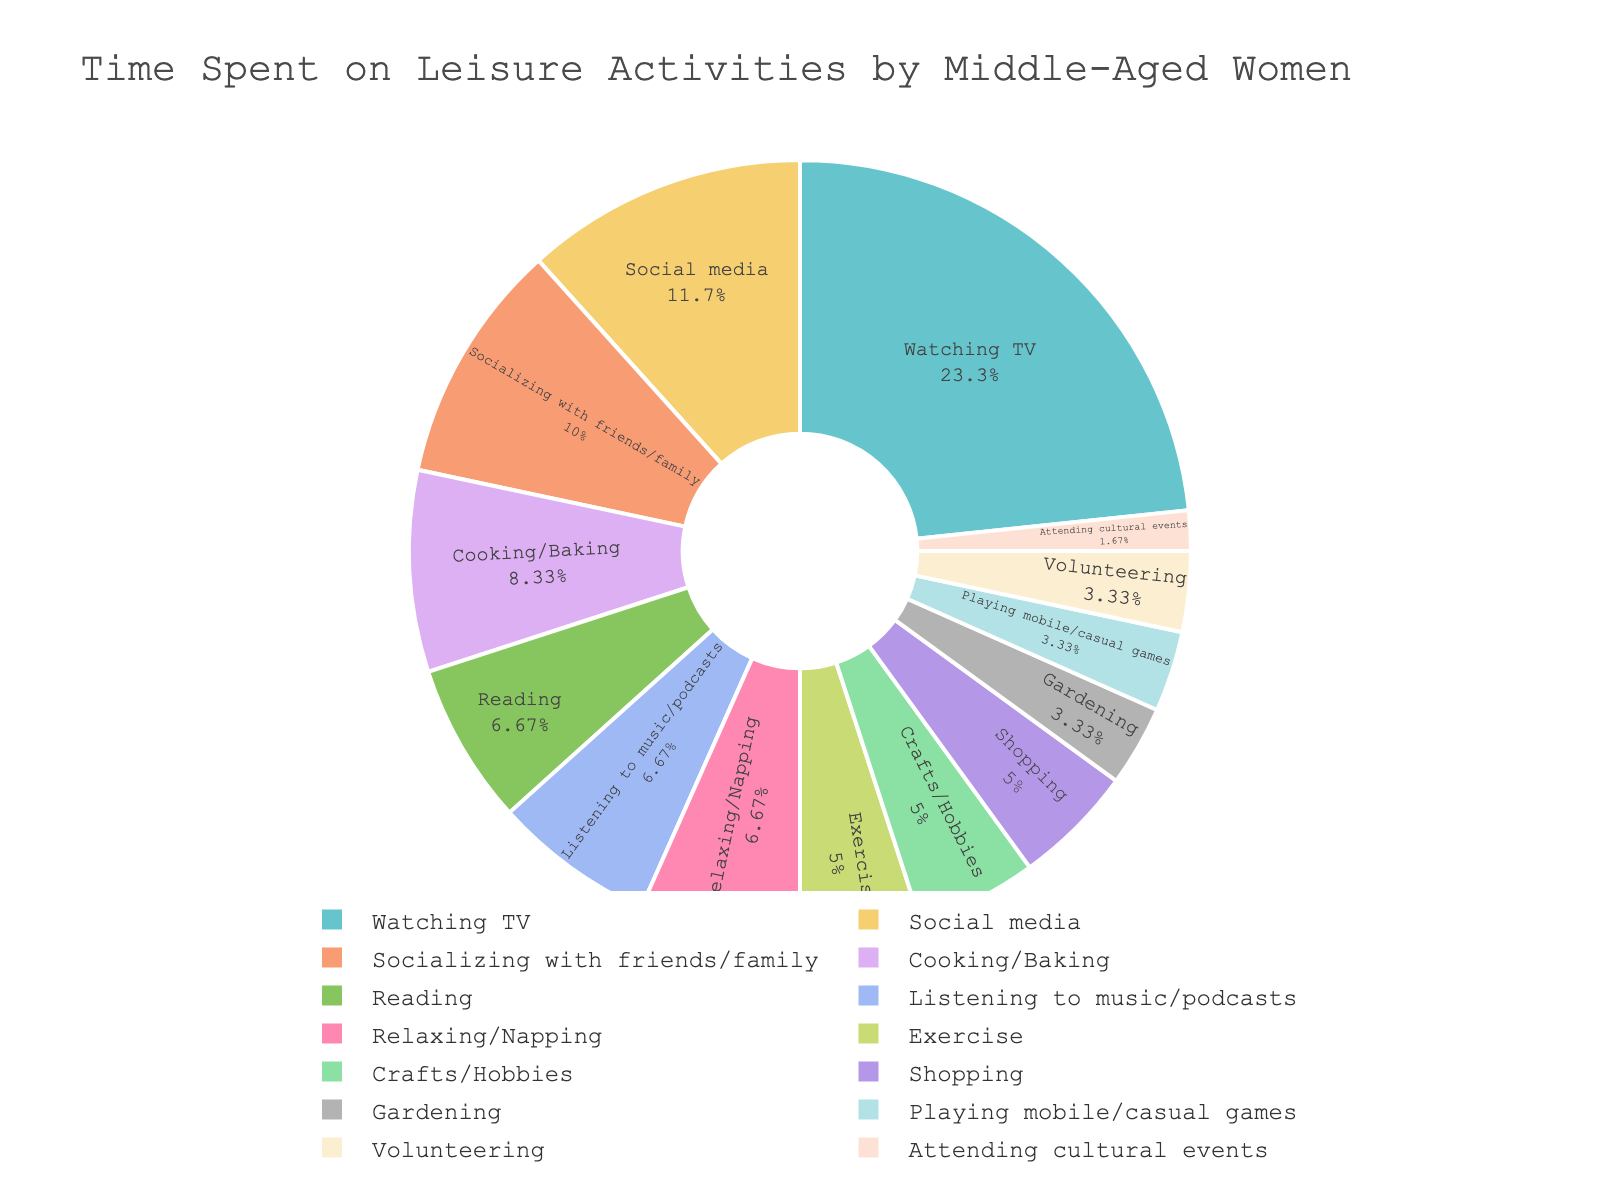What percentage of time is spent on Reading and Relaxing/Napping combined? Add the hours spent on Reading (4) and Relaxing/Napping (4) to get 8 hours. Calculate the combined percentage by dividing this by the total hours and multiplying by 100: \( \frac{8}{57} \times 100 \approx 14.04\% \)
Answer: 14.04% How many more hours per week are spent watching TV compared to Listening to music/podcasts? Subtract the hours spent Listening to music/podcasts (4) from the hours spent Watching TV (14): \( 14 - 4 = 10 \)
Answer: 10 Which activity takes up the largest percentage of time? Identify the activity with the largest slice in the pie chart, which is Watching TV.
Answer: Watching TV What is the combined percentage of time spent on Gardening, Playing mobile/casual games, and Volunteering? Add the hours spent on Gardening (2), Playing mobile/casual games (2), and Volunteering (2) to get 6 hours. Calculate the combined percentage: \( \frac{6}{57} \times 100 \approx 10.53\% \)
Answer: 10.53% Is more time spent on Cooking/Baking or on Social media? From the pie chart, compare the slices for Cooking/Baking (5 hours) and Social media (7 hours). Social media has a larger slice.
Answer: Social media What percentage of time is spent Socializing with friends/family? Identify the slice for Socializing with friends/family in the pie chart, which corresponds to 6 hours. Calculate the percentage: \( \frac{6}{57} \times 100 \approx 10.53\% \)
Answer: 10.53% What is the difference in time spent on Exercise and Shopping? Subtract the hours spent on Shopping (3) from the hours spent on Exercise (3): \( 3 - 3 = 0 \)
Answer: 0 Which two activities together make up approximately one-fifth of the total time? Find two activities whose combined hours equal approximately one-fifth of the total. Total hours are 57; one-fifth is approximately \( \frac{57}{5} \approx 11.4 \). Combining Social media (7 hours) and Cooking/Baking (5 hours) gives a total of 12 hours, which is close to 11.4. Calculate the combined percentage: \( \frac{12}{57} \times 100 \approx 21.05\% \)
Answer: Social media and Cooking/Baking How does the time spent on Socializing with friends/family compare to the time spent Listening to music/podcasts? From the pie chart, compare the slices: Socializing with friends/family (6 hours) and Listening to music/podcasts (4 hours). Socializing with friends/family is larger.
Answer: Socializing with friends/family 